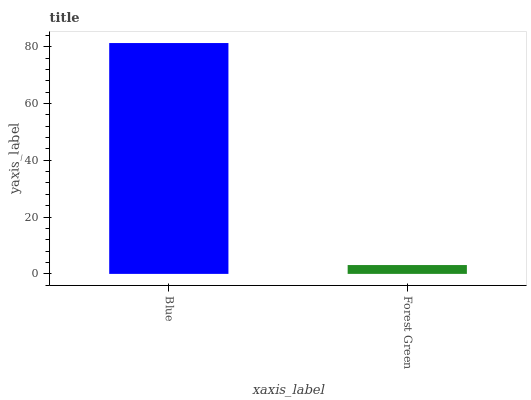Is Forest Green the minimum?
Answer yes or no. Yes. Is Blue the maximum?
Answer yes or no. Yes. Is Forest Green the maximum?
Answer yes or no. No. Is Blue greater than Forest Green?
Answer yes or no. Yes. Is Forest Green less than Blue?
Answer yes or no. Yes. Is Forest Green greater than Blue?
Answer yes or no. No. Is Blue less than Forest Green?
Answer yes or no. No. Is Blue the high median?
Answer yes or no. Yes. Is Forest Green the low median?
Answer yes or no. Yes. Is Forest Green the high median?
Answer yes or no. No. Is Blue the low median?
Answer yes or no. No. 